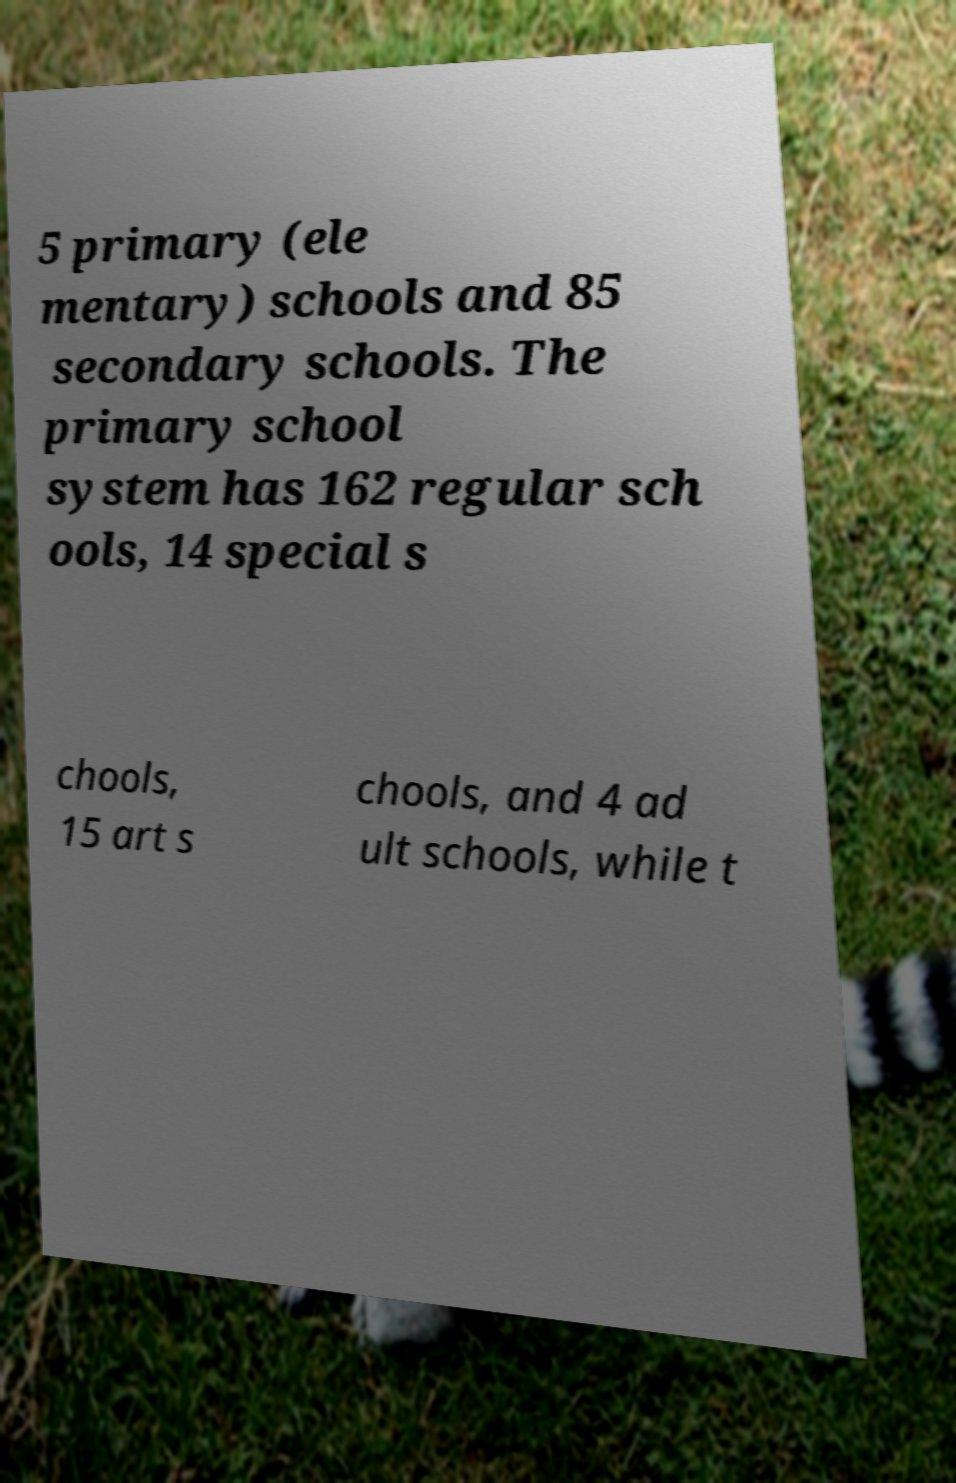Can you accurately transcribe the text from the provided image for me? 5 primary (ele mentary) schools and 85 secondary schools. The primary school system has 162 regular sch ools, 14 special s chools, 15 art s chools, and 4 ad ult schools, while t 